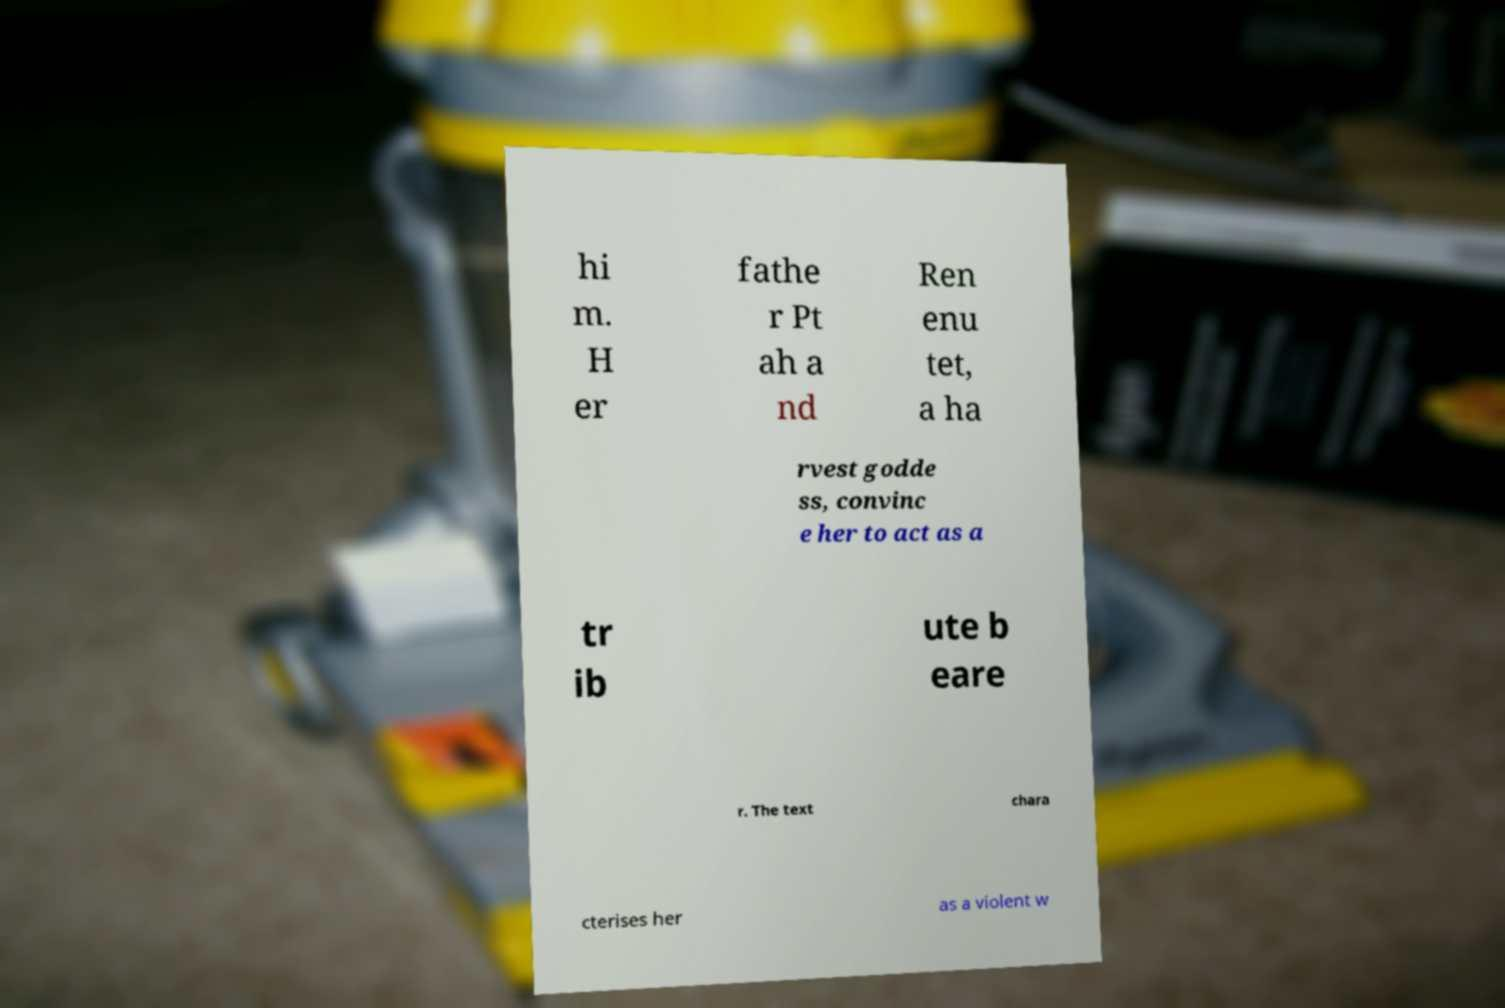Please identify and transcribe the text found in this image. hi m. H er fathe r Pt ah a nd Ren enu tet, a ha rvest godde ss, convinc e her to act as a tr ib ute b eare r. The text chara cterises her as a violent w 